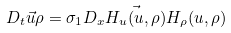<formula> <loc_0><loc_0><loc_500><loc_500>D _ { t } \vec { u } { \rho } = \sigma _ { 1 } D _ { x } \vec { H _ { u } ( u , \rho ) } { H _ { \rho } ( u , \rho ) }</formula> 